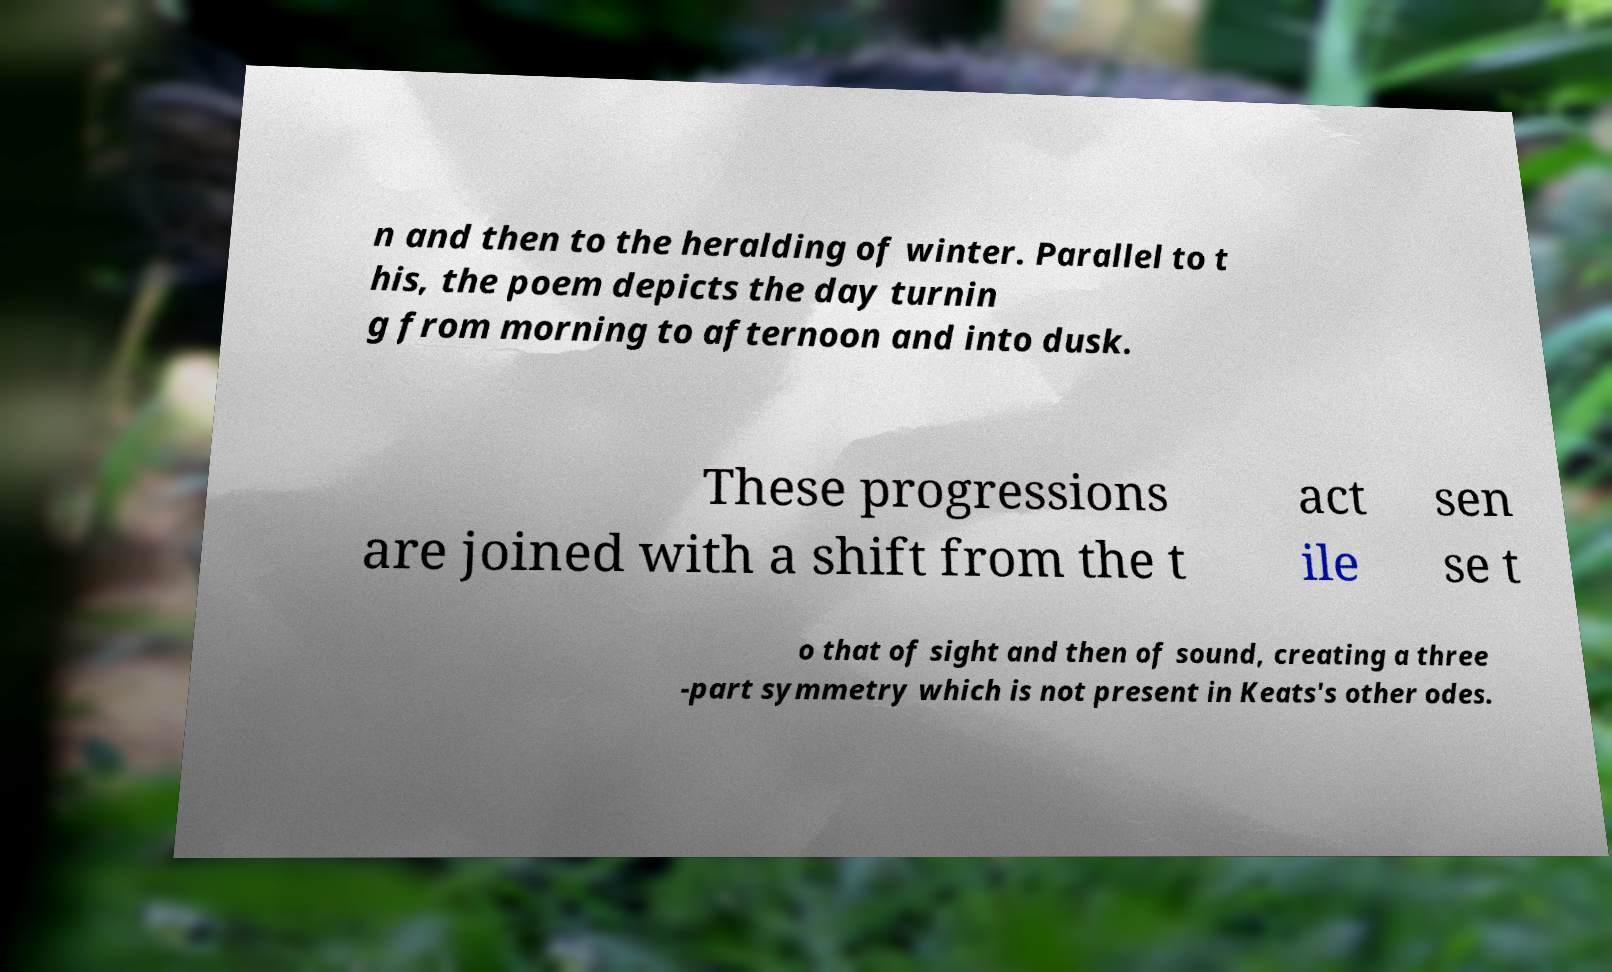Could you extract and type out the text from this image? n and then to the heralding of winter. Parallel to t his, the poem depicts the day turnin g from morning to afternoon and into dusk. These progressions are joined with a shift from the t act ile sen se t o that of sight and then of sound, creating a three -part symmetry which is not present in Keats's other odes. 